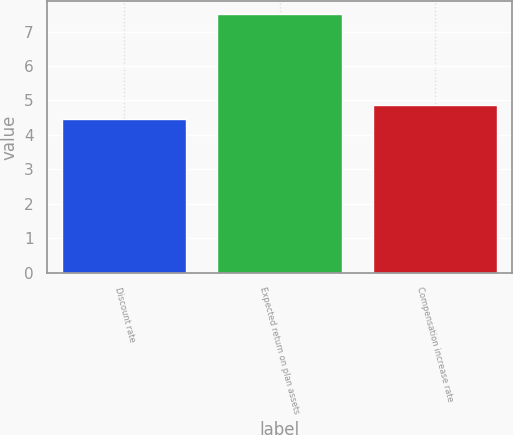Convert chart. <chart><loc_0><loc_0><loc_500><loc_500><bar_chart><fcel>Discount rate<fcel>Expected return on plan assets<fcel>Compensation increase rate<nl><fcel>4.47<fcel>7.5<fcel>4.87<nl></chart> 